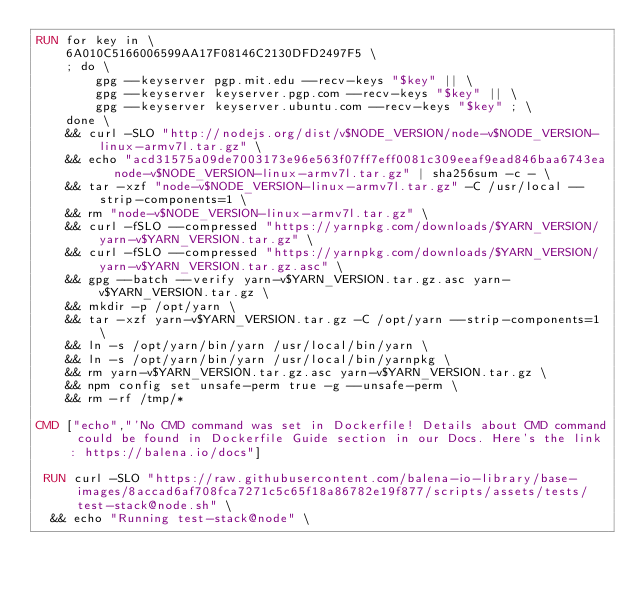Convert code to text. <code><loc_0><loc_0><loc_500><loc_500><_Dockerfile_>RUN for key in \
	6A010C5166006599AA17F08146C2130DFD2497F5 \
	; do \
		gpg --keyserver pgp.mit.edu --recv-keys "$key" || \
		gpg --keyserver keyserver.pgp.com --recv-keys "$key" || \
		gpg --keyserver keyserver.ubuntu.com --recv-keys "$key" ; \
	done \
	&& curl -SLO "http://nodejs.org/dist/v$NODE_VERSION/node-v$NODE_VERSION-linux-armv7l.tar.gz" \
	&& echo "acd31575a09de7003173e96e563f07ff7eff0081c309eeaf9ead846baa6743ea  node-v$NODE_VERSION-linux-armv7l.tar.gz" | sha256sum -c - \
	&& tar -xzf "node-v$NODE_VERSION-linux-armv7l.tar.gz" -C /usr/local --strip-components=1 \
	&& rm "node-v$NODE_VERSION-linux-armv7l.tar.gz" \
	&& curl -fSLO --compressed "https://yarnpkg.com/downloads/$YARN_VERSION/yarn-v$YARN_VERSION.tar.gz" \
	&& curl -fSLO --compressed "https://yarnpkg.com/downloads/$YARN_VERSION/yarn-v$YARN_VERSION.tar.gz.asc" \
	&& gpg --batch --verify yarn-v$YARN_VERSION.tar.gz.asc yarn-v$YARN_VERSION.tar.gz \
	&& mkdir -p /opt/yarn \
	&& tar -xzf yarn-v$YARN_VERSION.tar.gz -C /opt/yarn --strip-components=1 \
	&& ln -s /opt/yarn/bin/yarn /usr/local/bin/yarn \
	&& ln -s /opt/yarn/bin/yarn /usr/local/bin/yarnpkg \
	&& rm yarn-v$YARN_VERSION.tar.gz.asc yarn-v$YARN_VERSION.tar.gz \
	&& npm config set unsafe-perm true -g --unsafe-perm \
	&& rm -rf /tmp/*

CMD ["echo","'No CMD command was set in Dockerfile! Details about CMD command could be found in Dockerfile Guide section in our Docs. Here's the link: https://balena.io/docs"]

 RUN curl -SLO "https://raw.githubusercontent.com/balena-io-library/base-images/8accad6af708fca7271c5c65f18a86782e19f877/scripts/assets/tests/test-stack@node.sh" \
  && echo "Running test-stack@node" \</code> 